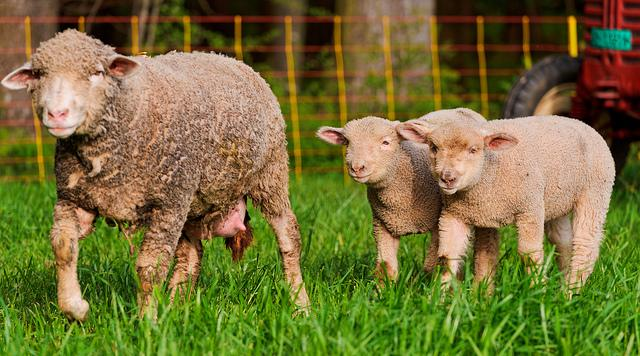How many lambs are lead by this sheep?

Choices:
A) three
B) four
C) two
D) one two 